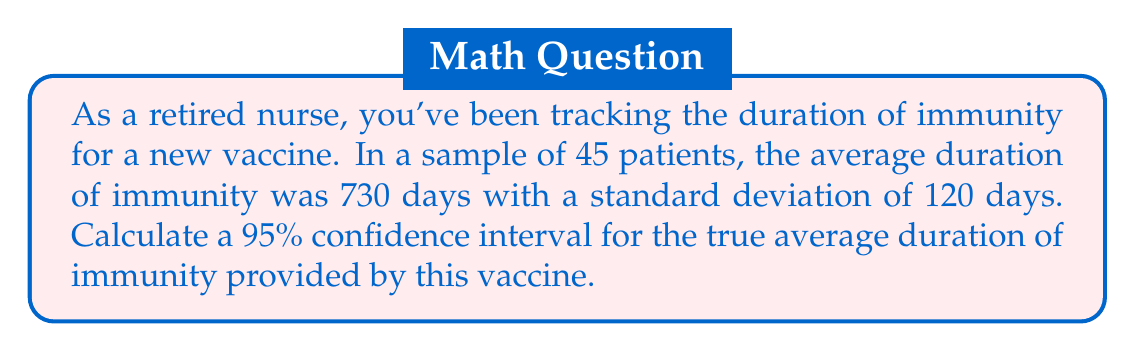Can you answer this question? To calculate the confidence interval, we'll follow these steps:

1) We're given:
   - Sample size (n) = 45
   - Sample mean ($\bar{x}$) = 730 days
   - Sample standard deviation (s) = 120 days
   - Confidence level = 95%

2) For a 95% confidence interval with n < 30, we use the t-distribution. The degrees of freedom (df) = n - 1 = 44.

3) Look up the t-value for a 95% confidence interval with 44 df. This is approximately 2.015.

4) Calculate the standard error (SE) of the mean:
   
   $SE = \frac{s}{\sqrt{n}} = \frac{120}{\sqrt{45}} = 17.89$

5) Calculate the margin of error:
   
   $Margin of Error = t \times SE = 2.015 \times 17.89 = 36.05$

6) The confidence interval is calculated as:
   
   $CI = \bar{x} \pm Margin of Error$
   
   $CI = 730 \pm 36.05$
   
   Lower bound: $730 - 36.05 = 693.95$
   Upper bound: $730 + 36.05 = 766.05$

Therefore, we can be 95% confident that the true average duration of immunity falls between 693.95 and 766.05 days.
Answer: (693.95, 766.05) days 